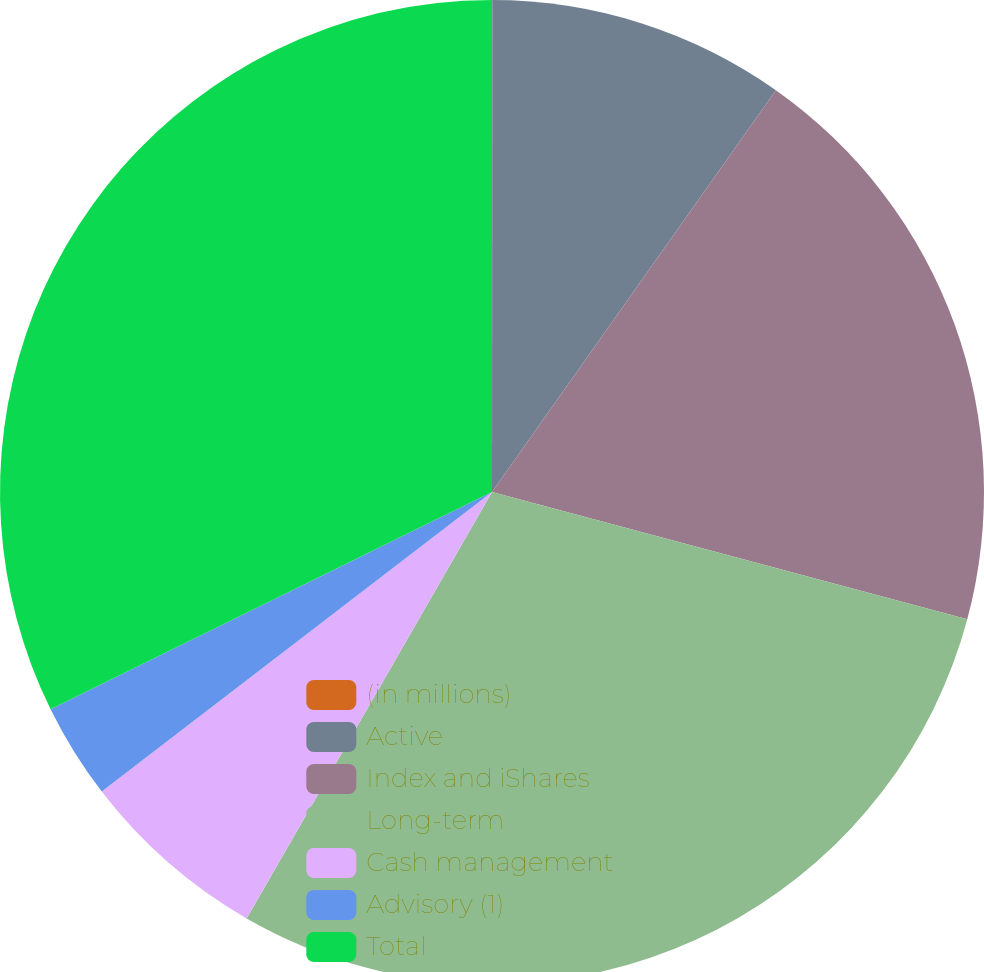Convert chart. <chart><loc_0><loc_0><loc_500><loc_500><pie_chart><fcel>(in millions)<fcel>Active<fcel>Index and iShares<fcel>Long-term<fcel>Cash management<fcel>Advisory (1)<fcel>Total<nl><fcel>0.01%<fcel>9.78%<fcel>19.37%<fcel>29.15%<fcel>6.27%<fcel>3.14%<fcel>32.28%<nl></chart> 